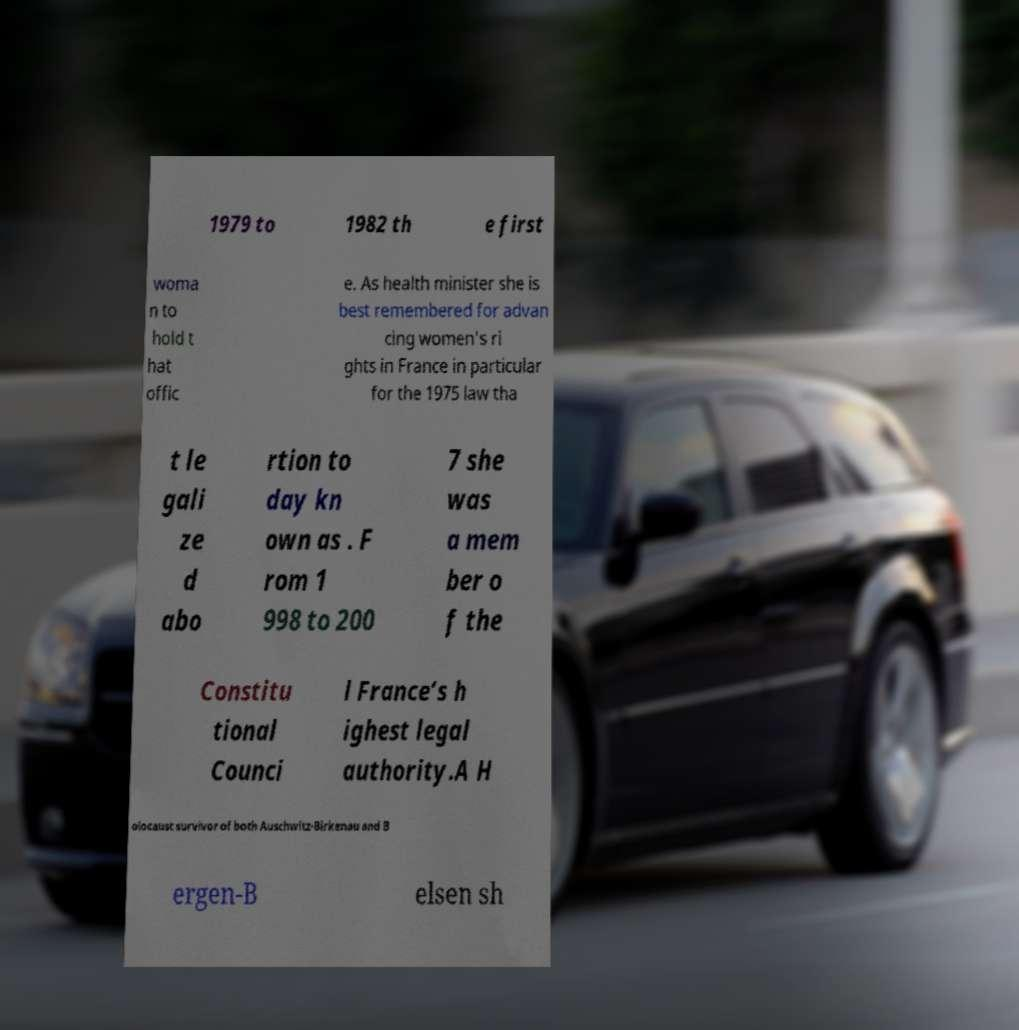Can you accurately transcribe the text from the provided image for me? 1979 to 1982 th e first woma n to hold t hat offic e. As health minister she is best remembered for advan cing women’s ri ghts in France in particular for the 1975 law tha t le gali ze d abo rtion to day kn own as . F rom 1 998 to 200 7 she was a mem ber o f the Constitu tional Counci l France’s h ighest legal authority.A H olocaust survivor of both Auschwitz-Birkenau and B ergen-B elsen sh 